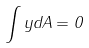<formula> <loc_0><loc_0><loc_500><loc_500>\int y d A = 0</formula> 